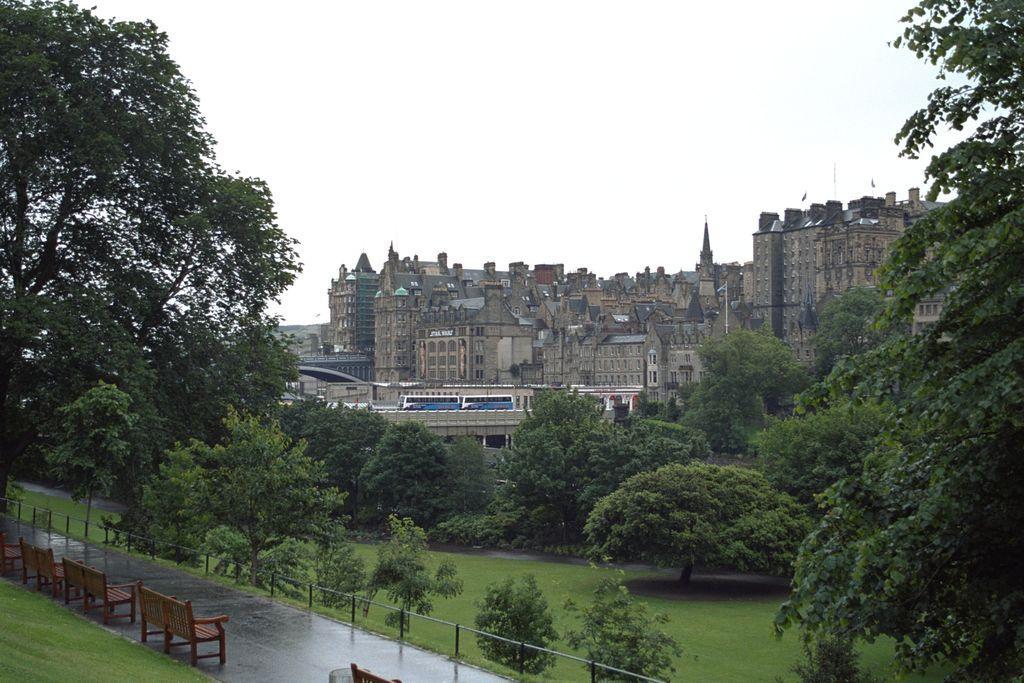Please provide a concise description of this image. In this image I can see the grass, the road, the railing, few benches on the road and few trees. In the background I can see few buildings, the bridge, few vehicles on the bridge and the sky. 